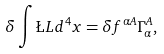<formula> <loc_0><loc_0><loc_500><loc_500>\delta \int \L L d ^ { 4 } x = \delta f ^ { \alpha A } \Gamma _ { \alpha } ^ { A } ,</formula> 